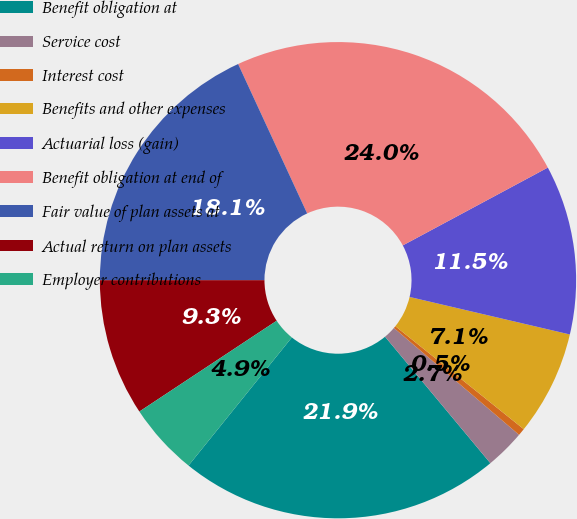Convert chart to OTSL. <chart><loc_0><loc_0><loc_500><loc_500><pie_chart><fcel>Benefit obligation at<fcel>Service cost<fcel>Interest cost<fcel>Benefits and other expenses<fcel>Actuarial loss (gain)<fcel>Benefit obligation at end of<fcel>Fair value of plan assets at<fcel>Actual return on plan assets<fcel>Employer contributions<nl><fcel>21.85%<fcel>2.7%<fcel>0.49%<fcel>7.1%<fcel>11.5%<fcel>24.05%<fcel>18.11%<fcel>9.3%<fcel>4.9%<nl></chart> 